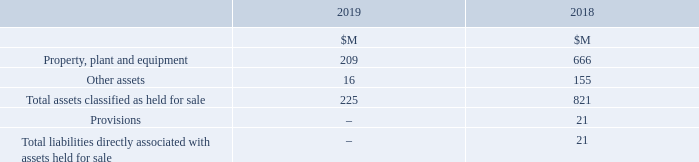This section sets out the assets and liabilities subject to a committed plan to sell.
At 30 June 2019, assets held for sale includes Group properties (2018: assets and liabilities relating to the Petrol business, and other Group properties, have been classified as held for sale).
Assets are classified as held for sale if their carrying amount will be recovered principally through a sale transaction rather than continuing use and a sale is considered highly probable. They are measured at the lower of their carrying amount and fair value less costs to sell, except for assets such as deferred tax assets, assets arising from employee benefits, and financial assets which are specifically exempt from this measurement requirement.
An impairment loss is recognised for any initial or subsequent write-down of the asset to fair value less costs to sell. A gain is recognised for any subsequent increases in fair value less costs to sell of an asset, but not in excess of any cumulative impairment loss previously recognised. A gain or loss not previously recognised by the date of the sale of the asset is recognised at the date of derecognition. Assets are not depreciated or amortised while they are classified as held for sale. Interest and other expenses attributable to the liabilities classified as held for sale continue to be recognised.
When are assets classified as held for sale? Assets are classified as held for sale if their carrying amount will be recovered principally through a sale transaction rather than continuing use and a sale is considered highly probable. When is an impairment loss recognised? An impairment loss is recognised for any initial or subsequent write-down of the asset to fair value less costs to sell. What is the total assets classified as held for sale in 2019?
Answer scale should be: million. 225. What is the difference in total assets classified as held for sale between 2018 and 2019?
Answer scale should be: million. 821 - 225 
Answer: 596. What is the difference in other assets between 2018 and 2019?
Answer scale should be: million. 155 - 16 
Answer: 139. What is the percentage change in property, plant and equipment between 2018 and 2019?
Answer scale should be: percent. (666 - 209)/666 
Answer: 68.62. 